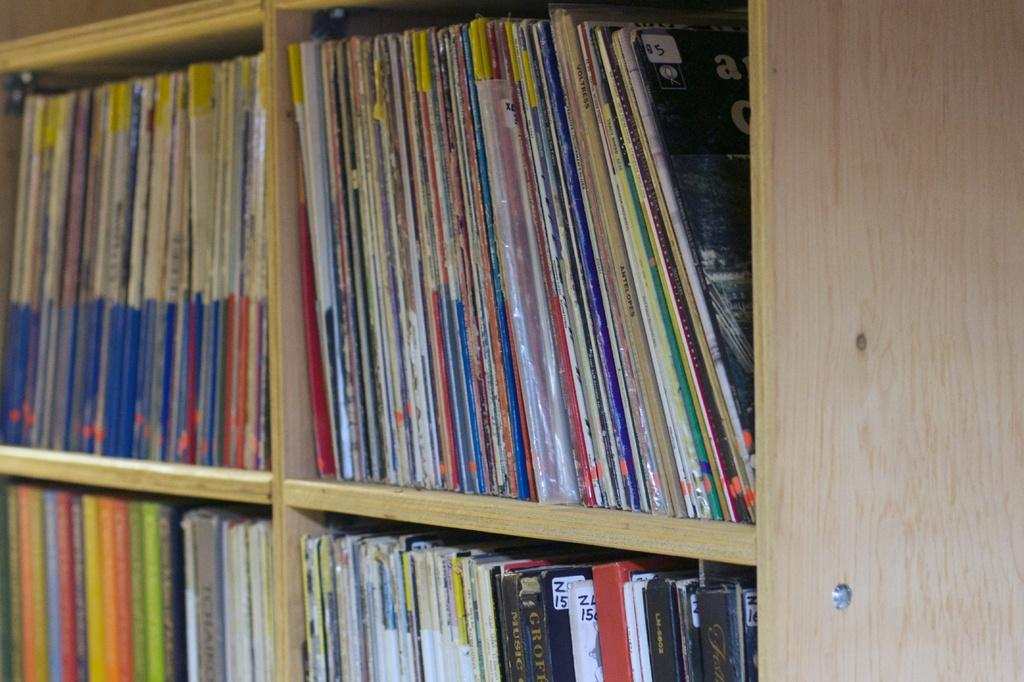What is the main subject of the image? The main subject of the image is many books. Where are the books located in the image? The books are in a rack. Can you see any toys among the books in the image? There are no toys present in the image; it only features books in a rack. What type of detail can be seen on the books' spines in the image? The provided facts do not mention any specific details on the books' spines, so we cannot answer this question definitively. 